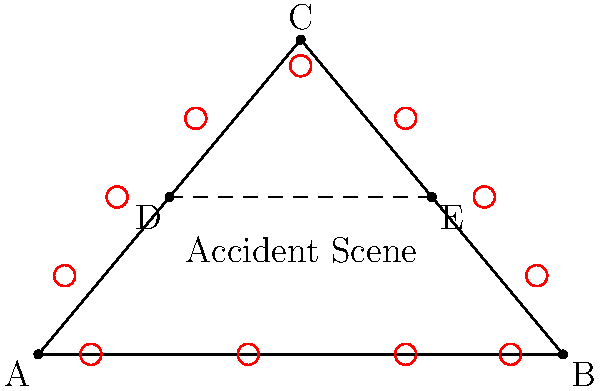Based on the diagram of an accident scene on a triangular intersection, what is the optimal number of traffic cones needed to secure the perimeter effectively while minimizing resource usage? To determine the optimal number of traffic cones, we need to consider several factors:

1. Perimeter coverage: The accident scene is represented by a triangular area, with sides AB, BC, and CA.

2. Cone spacing: For effective visibility and security, traffic cones should be placed approximately 10-15 feet apart.

3. Critical points: Special attention should be given to the vertices (A, B, C) and the entrance points (D, E) of the intersection.

4. Resource optimization: We want to use the minimum number of cones while maintaining safety.

Step-by-step analysis:
1. Measure the perimeter:
   AB ≈ 100 units
   BC ≈ 67 units
   CA ≈ 72 units
   Total perimeter ≈ 239 units

2. Convert units to feet (assuming 1 unit = 1 foot):
   Perimeter ≈ 239 feet

3. Calculate the number of cones needed based on 15-foot spacing:
   $\text{Number of cones} = \frac{\text{Perimeter}}{\text{Spacing}} = \frac{239}{15} \approx 16$ cones

4. Add extra cones for critical points:
   - 3 cones for vertices A, B, and C
   - 2 cones for entrance points D and E

5. Total optimal number of cones:
   16 (perimeter) + 3 (vertices) + 2 (entrances) = 21 cones

The diagram shows 11 cones, which is fewer than the calculated optimal number. This arrangement might be sufficient for immediate securing of the scene, but for comprehensive coverage, the calculated number would be more appropriate.
Answer: 21 cones 